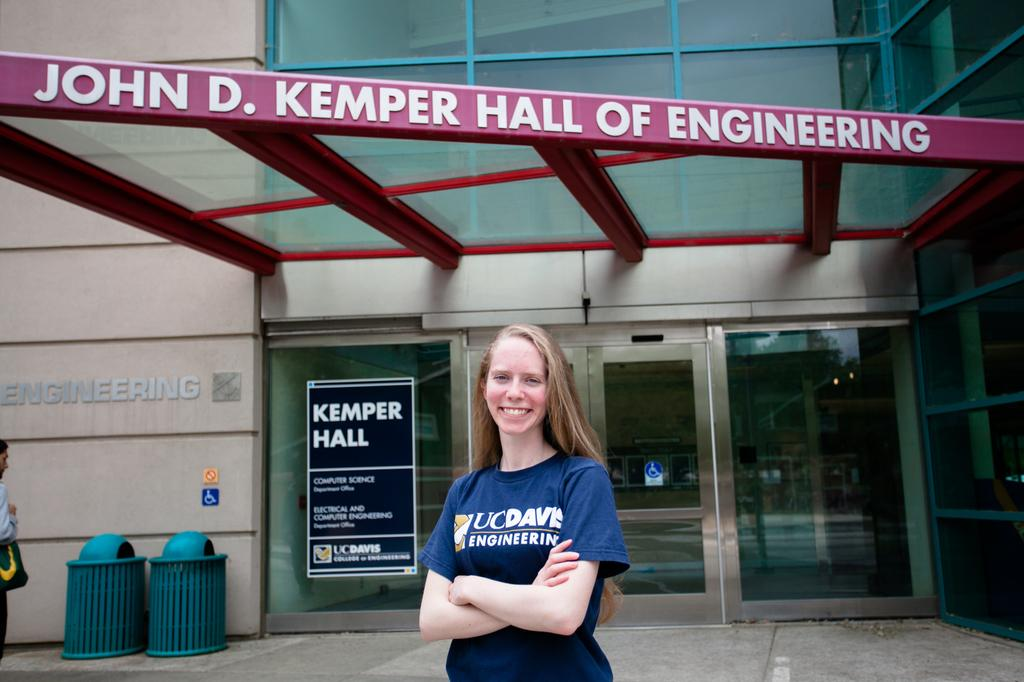<image>
Relay a brief, clear account of the picture shown. A girl standing in front of a building that is displaying a sign that says Kemper hall. 